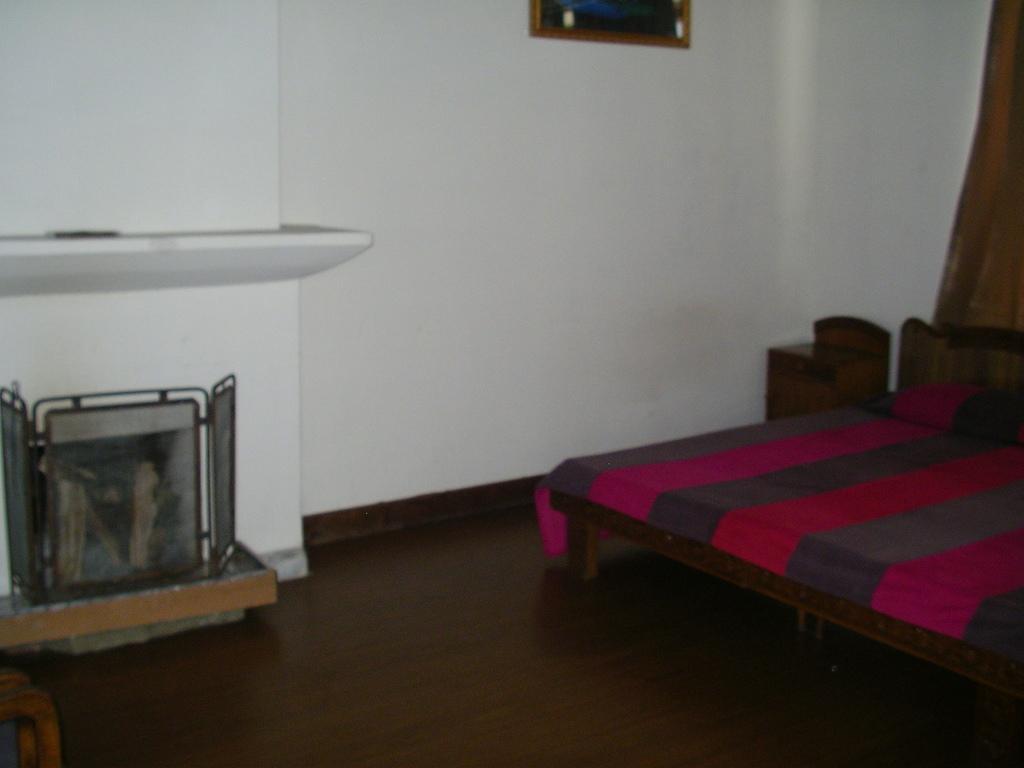In one or two sentences, can you explain what this image depicts? In the picture I can see bed, side we can see frame to the wall and one object is placed on the floor. 